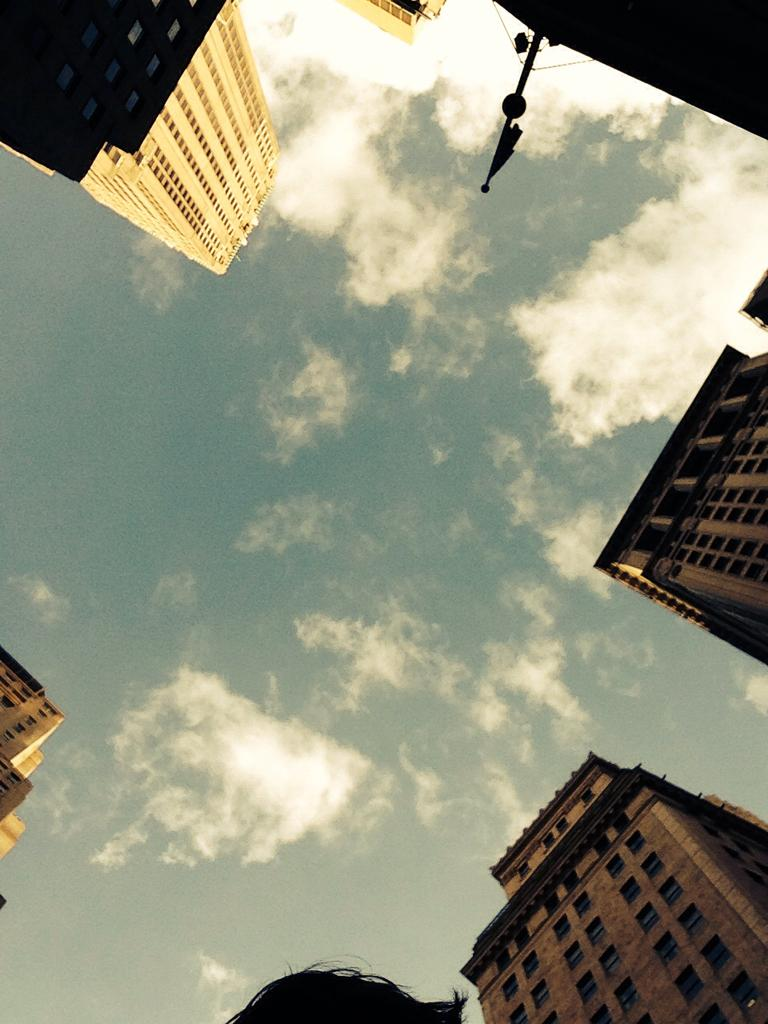What type of structures can be seen in the image? There are buildings in the image. What else is present in the image besides the buildings? There is a pole in the image. What part of the natural environment is visible in the image? The sky is visible in the image. What level of expertise does the beginner have with the flame in the image? There is no beginner or flame present in the image. How does the health of the buildings in the image compare to the health of the pole? There is no indication of the health of the buildings or the pole in the image. 